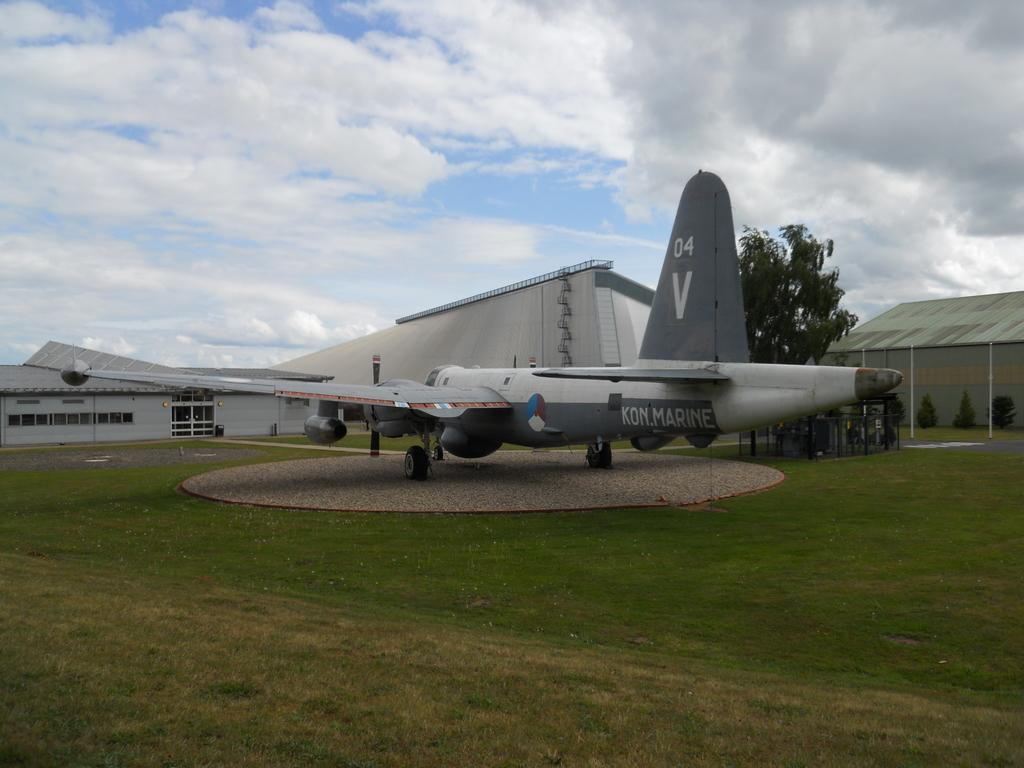What type of vegetation is present in the image? There is grass in the image. What type of vehicle is on the ground in the image? There is an aircraft on the ground in the image. What structures can be seen in the background of the image? There are houses in the background of the image. What can be seen in the sky in the background of the image? There are clouds in the sky in the background of the image. What type of approval is required to fly the aircraft in the image? The image does not provide information about the approval required to fly the aircraft, as it only shows the aircraft on the ground. How many days are in the week depicted in the image? The image does not depict a week or any time-related information; it only shows an aircraft on the ground, grass, houses, and clouds. 